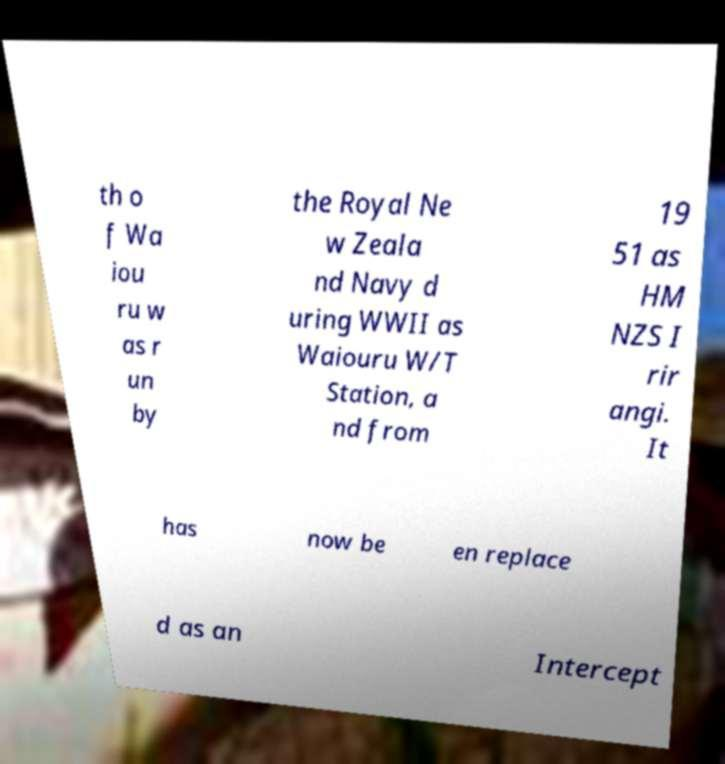Can you read and provide the text displayed in the image?This photo seems to have some interesting text. Can you extract and type it out for me? th o f Wa iou ru w as r un by the Royal Ne w Zeala nd Navy d uring WWII as Waiouru W/T Station, a nd from 19 51 as HM NZS I rir angi. It has now be en replace d as an Intercept 